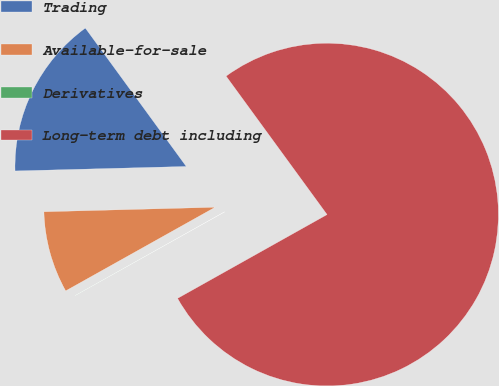Convert chart. <chart><loc_0><loc_0><loc_500><loc_500><pie_chart><fcel>Trading<fcel>Available-for-sale<fcel>Derivatives<fcel>Long-term debt including<nl><fcel>15.39%<fcel>7.7%<fcel>0.01%<fcel>76.9%<nl></chart> 